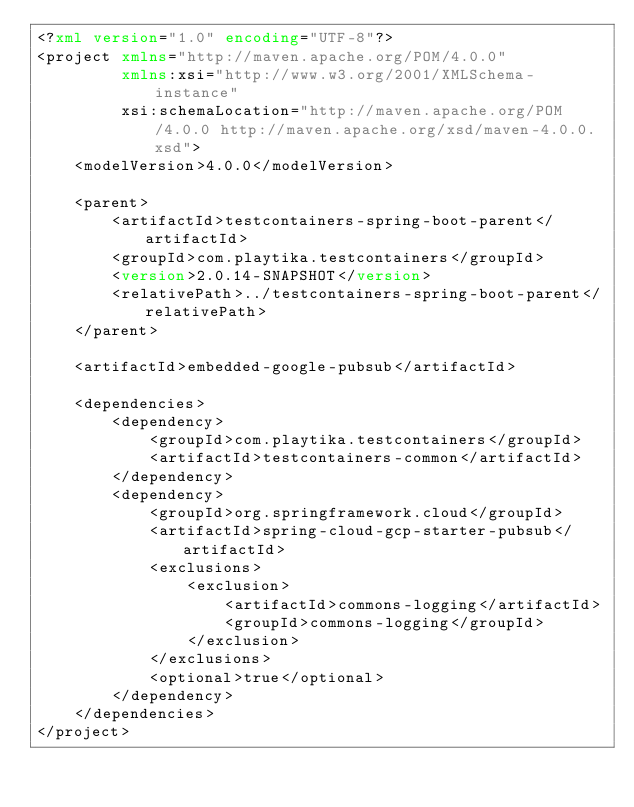Convert code to text. <code><loc_0><loc_0><loc_500><loc_500><_XML_><?xml version="1.0" encoding="UTF-8"?>
<project xmlns="http://maven.apache.org/POM/4.0.0"
         xmlns:xsi="http://www.w3.org/2001/XMLSchema-instance"
         xsi:schemaLocation="http://maven.apache.org/POM/4.0.0 http://maven.apache.org/xsd/maven-4.0.0.xsd">
    <modelVersion>4.0.0</modelVersion>

    <parent>
        <artifactId>testcontainers-spring-boot-parent</artifactId>
        <groupId>com.playtika.testcontainers</groupId>
        <version>2.0.14-SNAPSHOT</version>
        <relativePath>../testcontainers-spring-boot-parent</relativePath>
    </parent>

    <artifactId>embedded-google-pubsub</artifactId>

    <dependencies>
        <dependency>
            <groupId>com.playtika.testcontainers</groupId>
            <artifactId>testcontainers-common</artifactId>
        </dependency>
        <dependency>
            <groupId>org.springframework.cloud</groupId>
            <artifactId>spring-cloud-gcp-starter-pubsub</artifactId>
            <exclusions>
                <exclusion>
                    <artifactId>commons-logging</artifactId>
                    <groupId>commons-logging</groupId>
                </exclusion>
            </exclusions>
            <optional>true</optional>
        </dependency>
    </dependencies>
</project></code> 